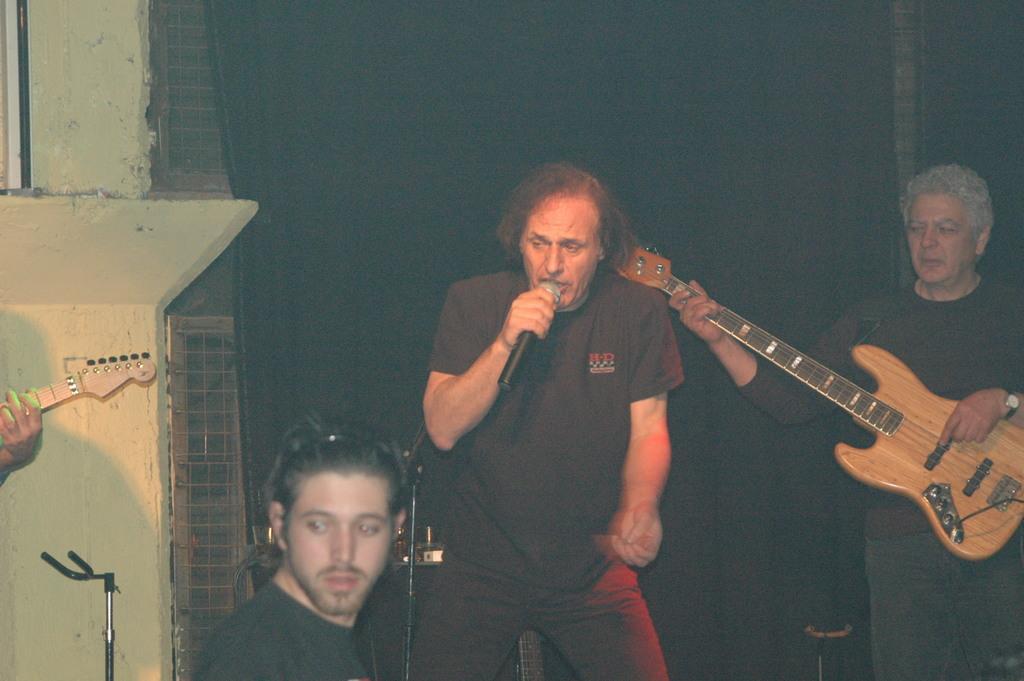How would you summarize this image in a sentence or two? This picture seems to be of outside. On the right there is a man wearing brown color t-shirt, standing and holding guitar. In the center there is a man wearing t-shirt, standing and singing. On the left there is a man wearing black color t-shirt. On the left corner there is a man seems to be playing guitar. In the background there is a wall and a curtain. 